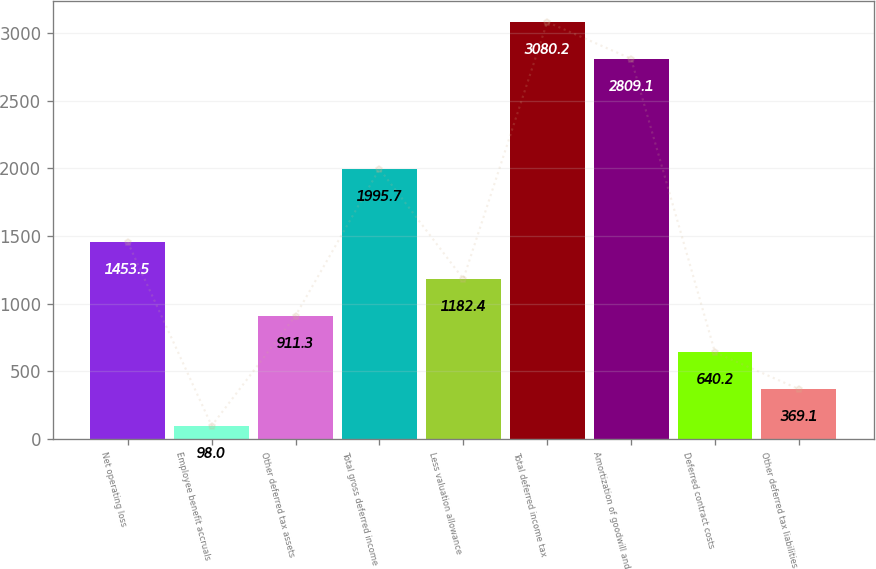Convert chart to OTSL. <chart><loc_0><loc_0><loc_500><loc_500><bar_chart><fcel>Net operating loss<fcel>Employee benefit accruals<fcel>Other deferred tax assets<fcel>Total gross deferred income<fcel>Less valuation allowance<fcel>Total deferred income tax<fcel>Amortization of goodwill and<fcel>Deferred contract costs<fcel>Other deferred tax liabilities<nl><fcel>1453.5<fcel>98<fcel>911.3<fcel>1995.7<fcel>1182.4<fcel>3080.2<fcel>2809.1<fcel>640.2<fcel>369.1<nl></chart> 